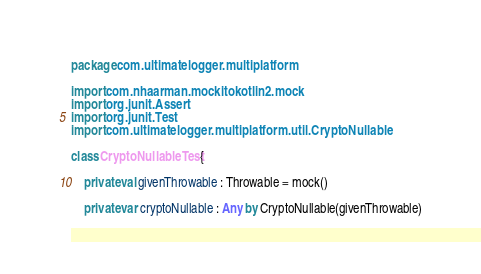Convert code to text. <code><loc_0><loc_0><loc_500><loc_500><_Kotlin_>package com.ultimatelogger.multiplatform

import com.nhaarman.mockitokotlin2.mock
import org.junit.Assert
import org.junit.Test
import com.ultimatelogger.multiplatform.util.CryptoNullable

class CryptoNullableTest {

    private val givenThrowable : Throwable = mock()

    private var cryptoNullable : Any by CryptoNullable(givenThrowable)
</code> 